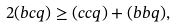<formula> <loc_0><loc_0><loc_500><loc_500>2 ( b c q ) \geq ( c c q ) + ( b b q ) ,</formula> 